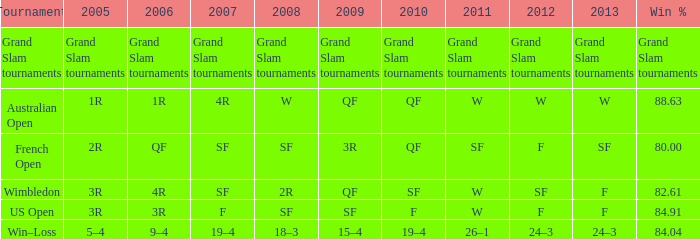What in 2007 contains a 2008 of sf, and a 2010 of f? F. 